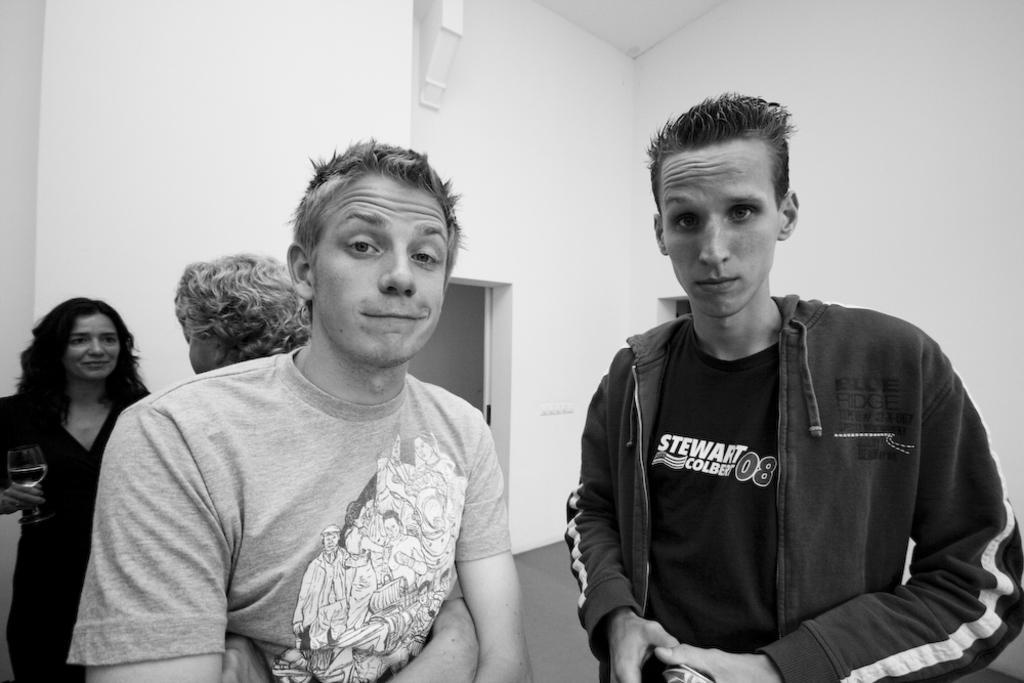Describe this image in one or two sentences. in the center of the image we can see four people standing. The lady on the left is holding a wine glass in her hand. In the background there is a door and a wall. 